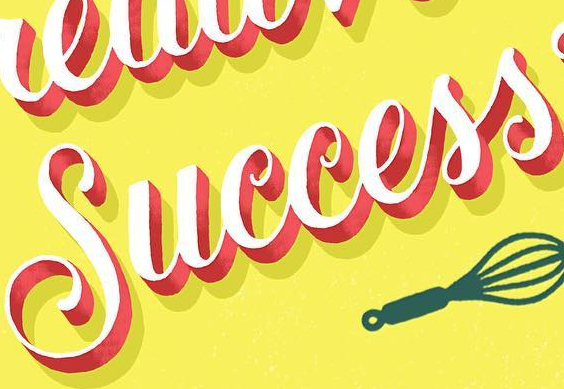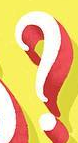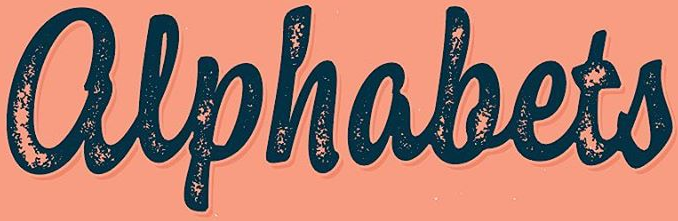Identify the words shown in these images in order, separated by a semicolon. Success; ?; alphabets 